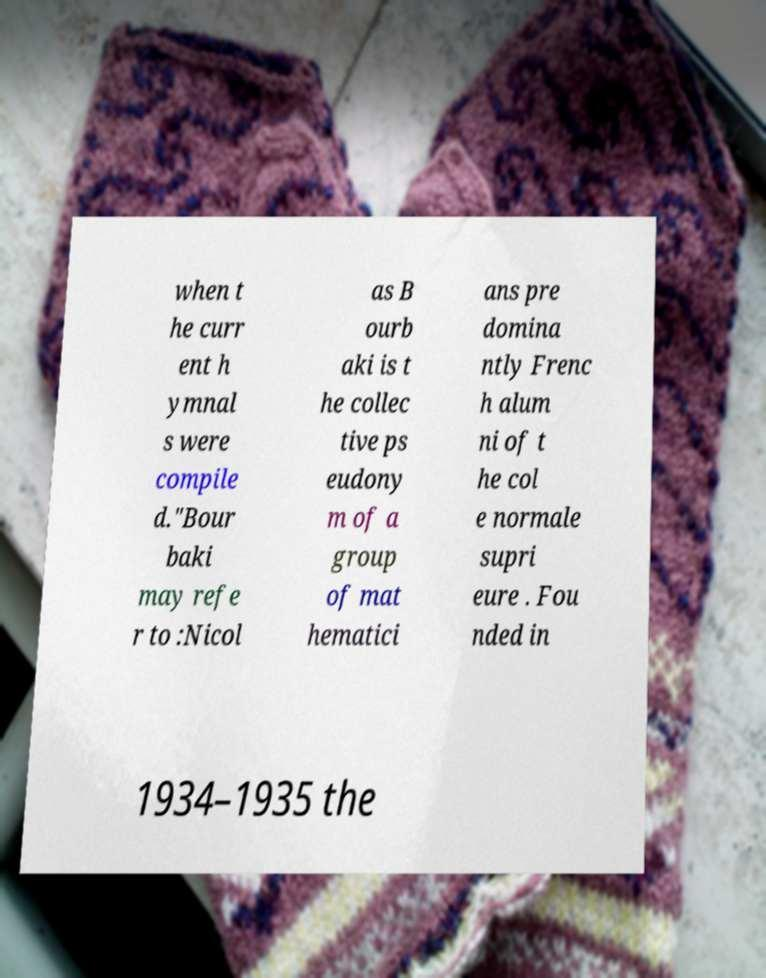Could you extract and type out the text from this image? when t he curr ent h ymnal s were compile d."Bour baki may refe r to :Nicol as B ourb aki is t he collec tive ps eudony m of a group of mat hematici ans pre domina ntly Frenc h alum ni of t he col e normale supri eure . Fou nded in 1934–1935 the 